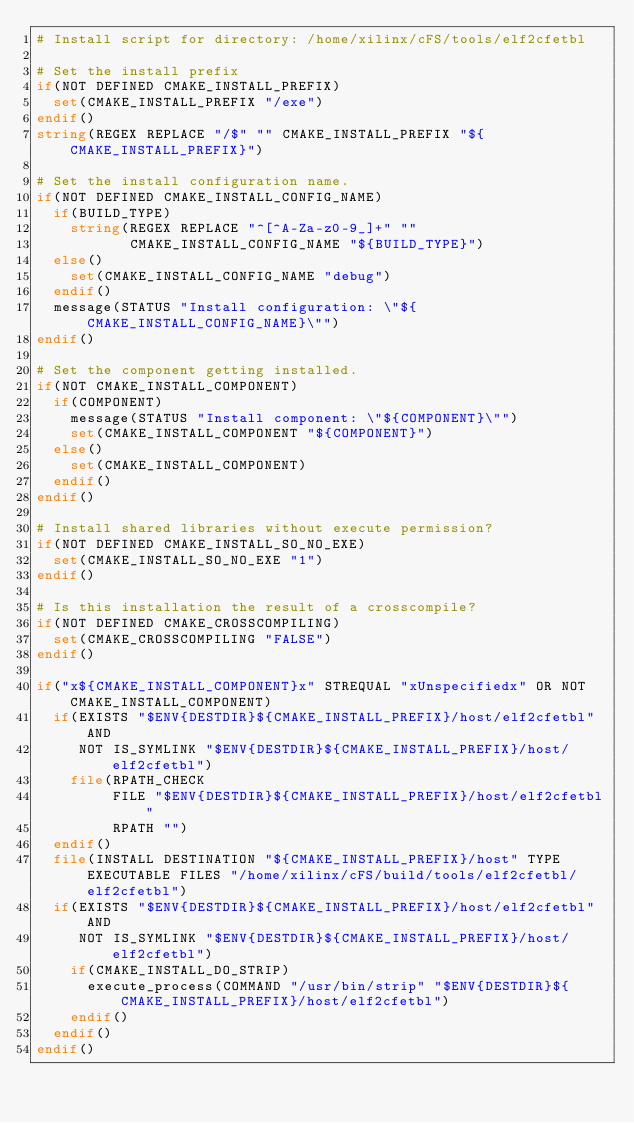Convert code to text. <code><loc_0><loc_0><loc_500><loc_500><_CMake_># Install script for directory: /home/xilinx/cFS/tools/elf2cfetbl

# Set the install prefix
if(NOT DEFINED CMAKE_INSTALL_PREFIX)
  set(CMAKE_INSTALL_PREFIX "/exe")
endif()
string(REGEX REPLACE "/$" "" CMAKE_INSTALL_PREFIX "${CMAKE_INSTALL_PREFIX}")

# Set the install configuration name.
if(NOT DEFINED CMAKE_INSTALL_CONFIG_NAME)
  if(BUILD_TYPE)
    string(REGEX REPLACE "^[^A-Za-z0-9_]+" ""
           CMAKE_INSTALL_CONFIG_NAME "${BUILD_TYPE}")
  else()
    set(CMAKE_INSTALL_CONFIG_NAME "debug")
  endif()
  message(STATUS "Install configuration: \"${CMAKE_INSTALL_CONFIG_NAME}\"")
endif()

# Set the component getting installed.
if(NOT CMAKE_INSTALL_COMPONENT)
  if(COMPONENT)
    message(STATUS "Install component: \"${COMPONENT}\"")
    set(CMAKE_INSTALL_COMPONENT "${COMPONENT}")
  else()
    set(CMAKE_INSTALL_COMPONENT)
  endif()
endif()

# Install shared libraries without execute permission?
if(NOT DEFINED CMAKE_INSTALL_SO_NO_EXE)
  set(CMAKE_INSTALL_SO_NO_EXE "1")
endif()

# Is this installation the result of a crosscompile?
if(NOT DEFINED CMAKE_CROSSCOMPILING)
  set(CMAKE_CROSSCOMPILING "FALSE")
endif()

if("x${CMAKE_INSTALL_COMPONENT}x" STREQUAL "xUnspecifiedx" OR NOT CMAKE_INSTALL_COMPONENT)
  if(EXISTS "$ENV{DESTDIR}${CMAKE_INSTALL_PREFIX}/host/elf2cfetbl" AND
     NOT IS_SYMLINK "$ENV{DESTDIR}${CMAKE_INSTALL_PREFIX}/host/elf2cfetbl")
    file(RPATH_CHECK
         FILE "$ENV{DESTDIR}${CMAKE_INSTALL_PREFIX}/host/elf2cfetbl"
         RPATH "")
  endif()
  file(INSTALL DESTINATION "${CMAKE_INSTALL_PREFIX}/host" TYPE EXECUTABLE FILES "/home/xilinx/cFS/build/tools/elf2cfetbl/elf2cfetbl")
  if(EXISTS "$ENV{DESTDIR}${CMAKE_INSTALL_PREFIX}/host/elf2cfetbl" AND
     NOT IS_SYMLINK "$ENV{DESTDIR}${CMAKE_INSTALL_PREFIX}/host/elf2cfetbl")
    if(CMAKE_INSTALL_DO_STRIP)
      execute_process(COMMAND "/usr/bin/strip" "$ENV{DESTDIR}${CMAKE_INSTALL_PREFIX}/host/elf2cfetbl")
    endif()
  endif()
endif()

</code> 